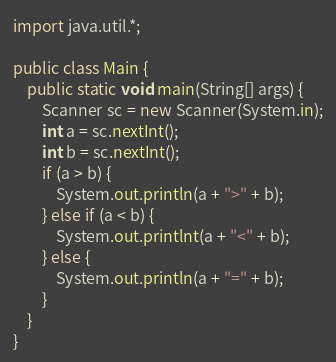<code> <loc_0><loc_0><loc_500><loc_500><_Java_>import java.util.*;

public class Main {
    public static void main(String[] args) {
        Scanner sc = new Scanner(System.in);
        int a = sc.nextInt();
        int b = sc.nextInt();
        if (a > b) {
            System.out.println(a + ">" + b);
        } else if (a < b) {
            System.out.printlnt(a + "<" + b);    
        } else {
            System.out.println(a + "=" + b);
        }
    }
}</code> 